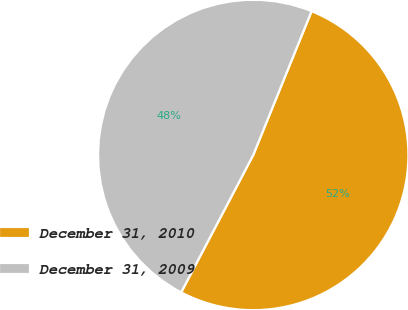<chart> <loc_0><loc_0><loc_500><loc_500><pie_chart><fcel>December 31, 2010<fcel>December 31, 2009<nl><fcel>51.56%<fcel>48.44%<nl></chart> 